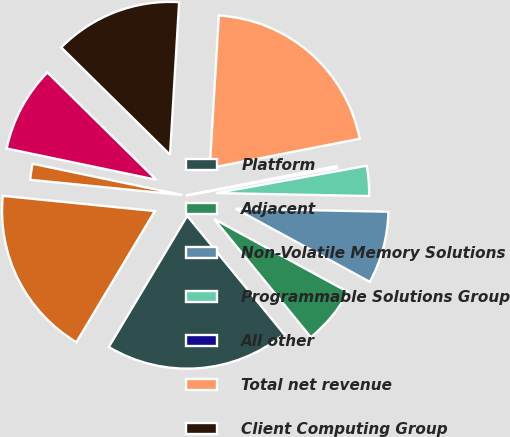Convert chart. <chart><loc_0><loc_0><loc_500><loc_500><pie_chart><fcel>Platform<fcel>Adjacent<fcel>Non-Volatile Memory Solutions<fcel>Programmable Solutions Group<fcel>All other<fcel>Total net revenue<fcel>Client Computing Group<fcel>Data Center Group<fcel>Internet of Things Group<fcel>Total operating income<nl><fcel>19.5%<fcel>6.14%<fcel>7.63%<fcel>3.17%<fcel>0.21%<fcel>20.98%<fcel>13.56%<fcel>9.11%<fcel>1.69%<fcel>18.01%<nl></chart> 